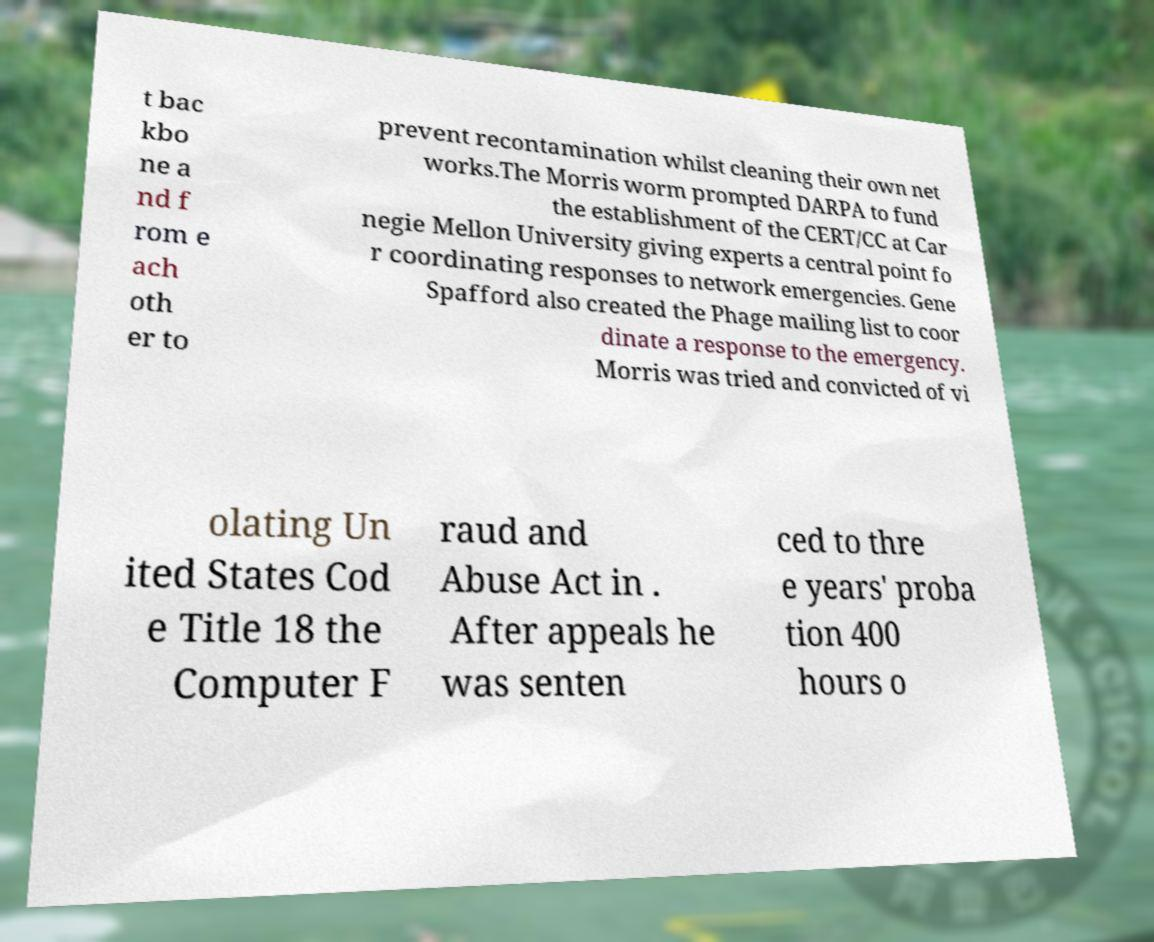Please read and relay the text visible in this image. What does it say? t bac kbo ne a nd f rom e ach oth er to prevent recontamination whilst cleaning their own net works.The Morris worm prompted DARPA to fund the establishment of the CERT/CC at Car negie Mellon University giving experts a central point fo r coordinating responses to network emergencies. Gene Spafford also created the Phage mailing list to coor dinate a response to the emergency. Morris was tried and convicted of vi olating Un ited States Cod e Title 18 the Computer F raud and Abuse Act in . After appeals he was senten ced to thre e years' proba tion 400 hours o 